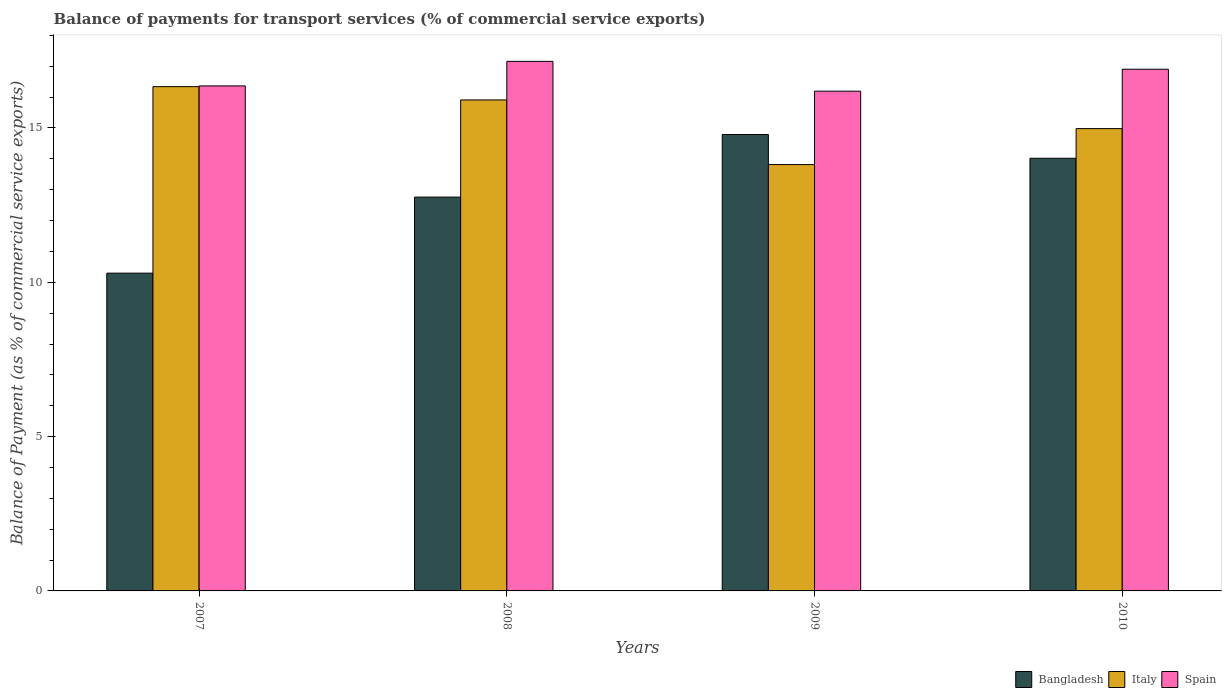Are the number of bars on each tick of the X-axis equal?
Provide a short and direct response. Yes. How many bars are there on the 1st tick from the left?
Provide a succinct answer. 3. What is the label of the 1st group of bars from the left?
Make the answer very short. 2007. In how many cases, is the number of bars for a given year not equal to the number of legend labels?
Give a very brief answer. 0. What is the balance of payments for transport services in Bangladesh in 2008?
Your answer should be very brief. 12.76. Across all years, what is the maximum balance of payments for transport services in Bangladesh?
Give a very brief answer. 14.79. Across all years, what is the minimum balance of payments for transport services in Bangladesh?
Provide a succinct answer. 10.3. What is the total balance of payments for transport services in Italy in the graph?
Make the answer very short. 61.04. What is the difference between the balance of payments for transport services in Spain in 2008 and that in 2010?
Provide a succinct answer. 0.26. What is the difference between the balance of payments for transport services in Spain in 2008 and the balance of payments for transport services in Bangladesh in 2007?
Offer a very short reply. 6.86. What is the average balance of payments for transport services in Bangladesh per year?
Make the answer very short. 12.97. In the year 2009, what is the difference between the balance of payments for transport services in Bangladesh and balance of payments for transport services in Spain?
Give a very brief answer. -1.4. What is the ratio of the balance of payments for transport services in Italy in 2007 to that in 2010?
Provide a short and direct response. 1.09. Is the balance of payments for transport services in Bangladesh in 2007 less than that in 2010?
Ensure brevity in your answer.  Yes. What is the difference between the highest and the second highest balance of payments for transport services in Italy?
Offer a terse response. 0.43. What is the difference between the highest and the lowest balance of payments for transport services in Spain?
Provide a short and direct response. 0.97. Is the sum of the balance of payments for transport services in Bangladesh in 2008 and 2010 greater than the maximum balance of payments for transport services in Spain across all years?
Keep it short and to the point. Yes. What does the 1st bar from the left in 2010 represents?
Ensure brevity in your answer.  Bangladesh. Is it the case that in every year, the sum of the balance of payments for transport services in Italy and balance of payments for transport services in Bangladesh is greater than the balance of payments for transport services in Spain?
Keep it short and to the point. Yes. How many bars are there?
Provide a succinct answer. 12. Are all the bars in the graph horizontal?
Keep it short and to the point. No. Are the values on the major ticks of Y-axis written in scientific E-notation?
Make the answer very short. No. Does the graph contain any zero values?
Your answer should be very brief. No. Does the graph contain grids?
Keep it short and to the point. No. What is the title of the graph?
Provide a short and direct response. Balance of payments for transport services (% of commercial service exports). Does "Paraguay" appear as one of the legend labels in the graph?
Your answer should be compact. No. What is the label or title of the X-axis?
Your answer should be very brief. Years. What is the label or title of the Y-axis?
Your answer should be compact. Balance of Payment (as % of commercial service exports). What is the Balance of Payment (as % of commercial service exports) in Bangladesh in 2007?
Provide a short and direct response. 10.3. What is the Balance of Payment (as % of commercial service exports) in Italy in 2007?
Your answer should be compact. 16.34. What is the Balance of Payment (as % of commercial service exports) in Spain in 2007?
Your answer should be very brief. 16.36. What is the Balance of Payment (as % of commercial service exports) of Bangladesh in 2008?
Your answer should be compact. 12.76. What is the Balance of Payment (as % of commercial service exports) of Italy in 2008?
Your answer should be very brief. 15.91. What is the Balance of Payment (as % of commercial service exports) in Spain in 2008?
Offer a terse response. 17.16. What is the Balance of Payment (as % of commercial service exports) of Bangladesh in 2009?
Your answer should be very brief. 14.79. What is the Balance of Payment (as % of commercial service exports) of Italy in 2009?
Provide a succinct answer. 13.81. What is the Balance of Payment (as % of commercial service exports) in Spain in 2009?
Provide a succinct answer. 16.19. What is the Balance of Payment (as % of commercial service exports) in Bangladesh in 2010?
Give a very brief answer. 14.02. What is the Balance of Payment (as % of commercial service exports) of Italy in 2010?
Offer a terse response. 14.98. What is the Balance of Payment (as % of commercial service exports) of Spain in 2010?
Your answer should be very brief. 16.9. Across all years, what is the maximum Balance of Payment (as % of commercial service exports) in Bangladesh?
Your answer should be very brief. 14.79. Across all years, what is the maximum Balance of Payment (as % of commercial service exports) of Italy?
Your answer should be compact. 16.34. Across all years, what is the maximum Balance of Payment (as % of commercial service exports) of Spain?
Your answer should be very brief. 17.16. Across all years, what is the minimum Balance of Payment (as % of commercial service exports) of Bangladesh?
Offer a very short reply. 10.3. Across all years, what is the minimum Balance of Payment (as % of commercial service exports) in Italy?
Ensure brevity in your answer.  13.81. Across all years, what is the minimum Balance of Payment (as % of commercial service exports) in Spain?
Give a very brief answer. 16.19. What is the total Balance of Payment (as % of commercial service exports) of Bangladesh in the graph?
Keep it short and to the point. 51.87. What is the total Balance of Payment (as % of commercial service exports) of Italy in the graph?
Keep it short and to the point. 61.04. What is the total Balance of Payment (as % of commercial service exports) of Spain in the graph?
Ensure brevity in your answer.  66.62. What is the difference between the Balance of Payment (as % of commercial service exports) of Bangladesh in 2007 and that in 2008?
Make the answer very short. -2.46. What is the difference between the Balance of Payment (as % of commercial service exports) of Italy in 2007 and that in 2008?
Provide a short and direct response. 0.43. What is the difference between the Balance of Payment (as % of commercial service exports) of Spain in 2007 and that in 2008?
Keep it short and to the point. -0.8. What is the difference between the Balance of Payment (as % of commercial service exports) in Bangladesh in 2007 and that in 2009?
Your answer should be compact. -4.49. What is the difference between the Balance of Payment (as % of commercial service exports) of Italy in 2007 and that in 2009?
Keep it short and to the point. 2.53. What is the difference between the Balance of Payment (as % of commercial service exports) in Spain in 2007 and that in 2009?
Give a very brief answer. 0.17. What is the difference between the Balance of Payment (as % of commercial service exports) in Bangladesh in 2007 and that in 2010?
Ensure brevity in your answer.  -3.72. What is the difference between the Balance of Payment (as % of commercial service exports) in Italy in 2007 and that in 2010?
Provide a succinct answer. 1.36. What is the difference between the Balance of Payment (as % of commercial service exports) in Spain in 2007 and that in 2010?
Give a very brief answer. -0.54. What is the difference between the Balance of Payment (as % of commercial service exports) in Bangladesh in 2008 and that in 2009?
Provide a succinct answer. -2.03. What is the difference between the Balance of Payment (as % of commercial service exports) of Italy in 2008 and that in 2009?
Make the answer very short. 2.09. What is the difference between the Balance of Payment (as % of commercial service exports) of Spain in 2008 and that in 2009?
Give a very brief answer. 0.97. What is the difference between the Balance of Payment (as % of commercial service exports) of Bangladesh in 2008 and that in 2010?
Offer a very short reply. -1.26. What is the difference between the Balance of Payment (as % of commercial service exports) of Italy in 2008 and that in 2010?
Offer a very short reply. 0.93. What is the difference between the Balance of Payment (as % of commercial service exports) in Spain in 2008 and that in 2010?
Provide a succinct answer. 0.26. What is the difference between the Balance of Payment (as % of commercial service exports) in Bangladesh in 2009 and that in 2010?
Ensure brevity in your answer.  0.77. What is the difference between the Balance of Payment (as % of commercial service exports) in Italy in 2009 and that in 2010?
Your answer should be very brief. -1.17. What is the difference between the Balance of Payment (as % of commercial service exports) in Spain in 2009 and that in 2010?
Your answer should be very brief. -0.71. What is the difference between the Balance of Payment (as % of commercial service exports) in Bangladesh in 2007 and the Balance of Payment (as % of commercial service exports) in Italy in 2008?
Your response must be concise. -5.61. What is the difference between the Balance of Payment (as % of commercial service exports) in Bangladesh in 2007 and the Balance of Payment (as % of commercial service exports) in Spain in 2008?
Offer a very short reply. -6.86. What is the difference between the Balance of Payment (as % of commercial service exports) in Italy in 2007 and the Balance of Payment (as % of commercial service exports) in Spain in 2008?
Offer a very short reply. -0.82. What is the difference between the Balance of Payment (as % of commercial service exports) of Bangladesh in 2007 and the Balance of Payment (as % of commercial service exports) of Italy in 2009?
Offer a very short reply. -3.52. What is the difference between the Balance of Payment (as % of commercial service exports) in Bangladesh in 2007 and the Balance of Payment (as % of commercial service exports) in Spain in 2009?
Ensure brevity in your answer.  -5.9. What is the difference between the Balance of Payment (as % of commercial service exports) of Italy in 2007 and the Balance of Payment (as % of commercial service exports) of Spain in 2009?
Make the answer very short. 0.15. What is the difference between the Balance of Payment (as % of commercial service exports) in Bangladesh in 2007 and the Balance of Payment (as % of commercial service exports) in Italy in 2010?
Make the answer very short. -4.68. What is the difference between the Balance of Payment (as % of commercial service exports) of Bangladesh in 2007 and the Balance of Payment (as % of commercial service exports) of Spain in 2010?
Give a very brief answer. -6.61. What is the difference between the Balance of Payment (as % of commercial service exports) of Italy in 2007 and the Balance of Payment (as % of commercial service exports) of Spain in 2010?
Offer a terse response. -0.56. What is the difference between the Balance of Payment (as % of commercial service exports) in Bangladesh in 2008 and the Balance of Payment (as % of commercial service exports) in Italy in 2009?
Keep it short and to the point. -1.05. What is the difference between the Balance of Payment (as % of commercial service exports) of Bangladesh in 2008 and the Balance of Payment (as % of commercial service exports) of Spain in 2009?
Ensure brevity in your answer.  -3.43. What is the difference between the Balance of Payment (as % of commercial service exports) of Italy in 2008 and the Balance of Payment (as % of commercial service exports) of Spain in 2009?
Your answer should be compact. -0.28. What is the difference between the Balance of Payment (as % of commercial service exports) of Bangladesh in 2008 and the Balance of Payment (as % of commercial service exports) of Italy in 2010?
Ensure brevity in your answer.  -2.22. What is the difference between the Balance of Payment (as % of commercial service exports) in Bangladesh in 2008 and the Balance of Payment (as % of commercial service exports) in Spain in 2010?
Give a very brief answer. -4.14. What is the difference between the Balance of Payment (as % of commercial service exports) of Italy in 2008 and the Balance of Payment (as % of commercial service exports) of Spain in 2010?
Provide a short and direct response. -1. What is the difference between the Balance of Payment (as % of commercial service exports) of Bangladesh in 2009 and the Balance of Payment (as % of commercial service exports) of Italy in 2010?
Offer a terse response. -0.19. What is the difference between the Balance of Payment (as % of commercial service exports) in Bangladesh in 2009 and the Balance of Payment (as % of commercial service exports) in Spain in 2010?
Your response must be concise. -2.12. What is the difference between the Balance of Payment (as % of commercial service exports) in Italy in 2009 and the Balance of Payment (as % of commercial service exports) in Spain in 2010?
Offer a terse response. -3.09. What is the average Balance of Payment (as % of commercial service exports) in Bangladesh per year?
Your response must be concise. 12.97. What is the average Balance of Payment (as % of commercial service exports) in Italy per year?
Provide a short and direct response. 15.26. What is the average Balance of Payment (as % of commercial service exports) of Spain per year?
Offer a very short reply. 16.65. In the year 2007, what is the difference between the Balance of Payment (as % of commercial service exports) in Bangladesh and Balance of Payment (as % of commercial service exports) in Italy?
Offer a terse response. -6.04. In the year 2007, what is the difference between the Balance of Payment (as % of commercial service exports) of Bangladesh and Balance of Payment (as % of commercial service exports) of Spain?
Keep it short and to the point. -6.07. In the year 2007, what is the difference between the Balance of Payment (as % of commercial service exports) of Italy and Balance of Payment (as % of commercial service exports) of Spain?
Keep it short and to the point. -0.02. In the year 2008, what is the difference between the Balance of Payment (as % of commercial service exports) in Bangladesh and Balance of Payment (as % of commercial service exports) in Italy?
Your answer should be compact. -3.15. In the year 2008, what is the difference between the Balance of Payment (as % of commercial service exports) of Bangladesh and Balance of Payment (as % of commercial service exports) of Spain?
Offer a terse response. -4.4. In the year 2008, what is the difference between the Balance of Payment (as % of commercial service exports) in Italy and Balance of Payment (as % of commercial service exports) in Spain?
Offer a very short reply. -1.25. In the year 2009, what is the difference between the Balance of Payment (as % of commercial service exports) in Bangladesh and Balance of Payment (as % of commercial service exports) in Italy?
Your answer should be very brief. 0.97. In the year 2009, what is the difference between the Balance of Payment (as % of commercial service exports) in Bangladesh and Balance of Payment (as % of commercial service exports) in Spain?
Provide a short and direct response. -1.4. In the year 2009, what is the difference between the Balance of Payment (as % of commercial service exports) in Italy and Balance of Payment (as % of commercial service exports) in Spain?
Provide a short and direct response. -2.38. In the year 2010, what is the difference between the Balance of Payment (as % of commercial service exports) of Bangladesh and Balance of Payment (as % of commercial service exports) of Italy?
Keep it short and to the point. -0.96. In the year 2010, what is the difference between the Balance of Payment (as % of commercial service exports) in Bangladesh and Balance of Payment (as % of commercial service exports) in Spain?
Offer a very short reply. -2.88. In the year 2010, what is the difference between the Balance of Payment (as % of commercial service exports) of Italy and Balance of Payment (as % of commercial service exports) of Spain?
Provide a succinct answer. -1.92. What is the ratio of the Balance of Payment (as % of commercial service exports) in Bangladesh in 2007 to that in 2008?
Provide a succinct answer. 0.81. What is the ratio of the Balance of Payment (as % of commercial service exports) of Italy in 2007 to that in 2008?
Your answer should be very brief. 1.03. What is the ratio of the Balance of Payment (as % of commercial service exports) in Spain in 2007 to that in 2008?
Offer a terse response. 0.95. What is the ratio of the Balance of Payment (as % of commercial service exports) of Bangladesh in 2007 to that in 2009?
Your answer should be compact. 0.7. What is the ratio of the Balance of Payment (as % of commercial service exports) of Italy in 2007 to that in 2009?
Provide a short and direct response. 1.18. What is the ratio of the Balance of Payment (as % of commercial service exports) in Spain in 2007 to that in 2009?
Offer a terse response. 1.01. What is the ratio of the Balance of Payment (as % of commercial service exports) of Bangladesh in 2007 to that in 2010?
Offer a terse response. 0.73. What is the ratio of the Balance of Payment (as % of commercial service exports) in Italy in 2007 to that in 2010?
Keep it short and to the point. 1.09. What is the ratio of the Balance of Payment (as % of commercial service exports) in Bangladesh in 2008 to that in 2009?
Provide a succinct answer. 0.86. What is the ratio of the Balance of Payment (as % of commercial service exports) in Italy in 2008 to that in 2009?
Your answer should be compact. 1.15. What is the ratio of the Balance of Payment (as % of commercial service exports) of Spain in 2008 to that in 2009?
Your answer should be compact. 1.06. What is the ratio of the Balance of Payment (as % of commercial service exports) of Bangladesh in 2008 to that in 2010?
Make the answer very short. 0.91. What is the ratio of the Balance of Payment (as % of commercial service exports) in Italy in 2008 to that in 2010?
Keep it short and to the point. 1.06. What is the ratio of the Balance of Payment (as % of commercial service exports) of Spain in 2008 to that in 2010?
Provide a succinct answer. 1.02. What is the ratio of the Balance of Payment (as % of commercial service exports) in Bangladesh in 2009 to that in 2010?
Ensure brevity in your answer.  1.05. What is the ratio of the Balance of Payment (as % of commercial service exports) of Italy in 2009 to that in 2010?
Make the answer very short. 0.92. What is the ratio of the Balance of Payment (as % of commercial service exports) in Spain in 2009 to that in 2010?
Offer a terse response. 0.96. What is the difference between the highest and the second highest Balance of Payment (as % of commercial service exports) in Bangladesh?
Provide a short and direct response. 0.77. What is the difference between the highest and the second highest Balance of Payment (as % of commercial service exports) in Italy?
Offer a terse response. 0.43. What is the difference between the highest and the second highest Balance of Payment (as % of commercial service exports) in Spain?
Ensure brevity in your answer.  0.26. What is the difference between the highest and the lowest Balance of Payment (as % of commercial service exports) in Bangladesh?
Your response must be concise. 4.49. What is the difference between the highest and the lowest Balance of Payment (as % of commercial service exports) of Italy?
Give a very brief answer. 2.53. What is the difference between the highest and the lowest Balance of Payment (as % of commercial service exports) in Spain?
Give a very brief answer. 0.97. 